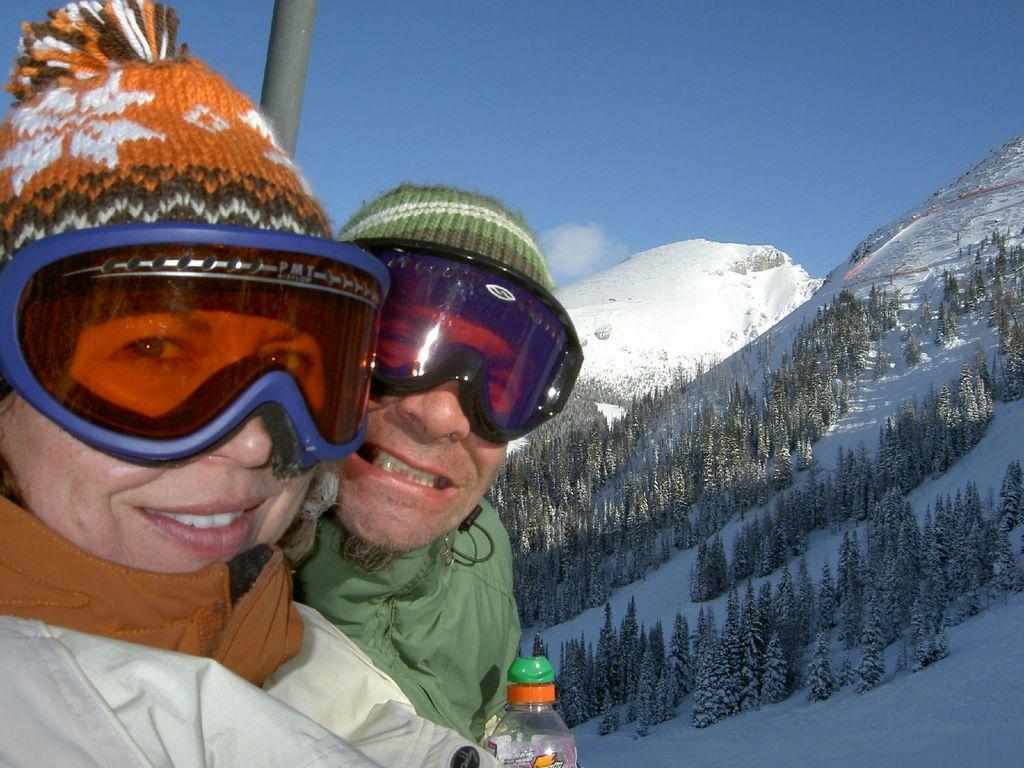How many people are in the image? There are two people in the image. What are the people doing in the image? The people are standing together. What type of clothing are the people wearing? The people are wearing jackets, glasses, and monkey caps. What can be seen in the background of the image? There are mountains with trees in the image. What is the condition of the trees in the image? The trees are covered with snow. What type of clam can be seen in the image? There are no clams present in the image; it features two people standing together and a snowy mountainous background. Can you tell me how many pencils are being used by the people in the image? There is no indication that the people in the image are using pencils, as they are wearing jackets, glasses, and monkey caps. 